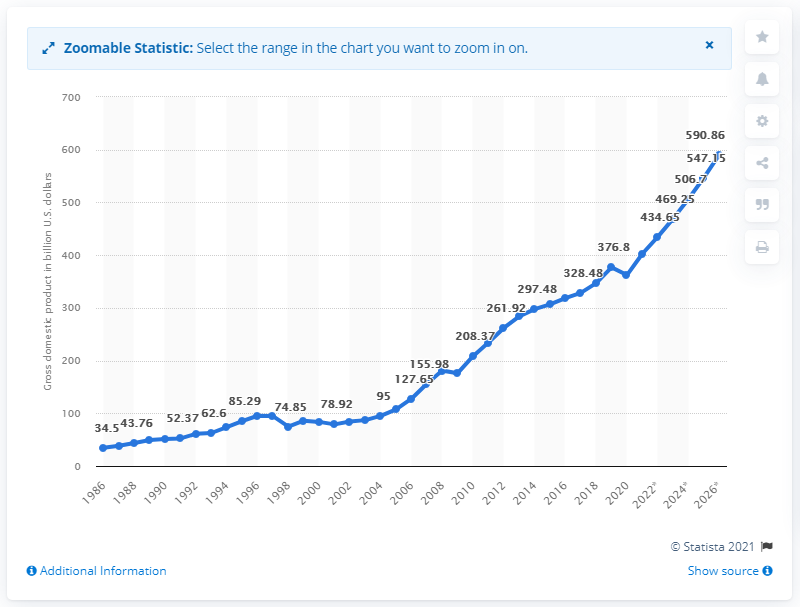Point out several critical features in this image. The projected Gross Domestic Product (GDP) of the Philippines by 2026 is expected to be 590.86. The Philippines' gross domestic product in 2020 was approximately 362.24 billion dollars. 